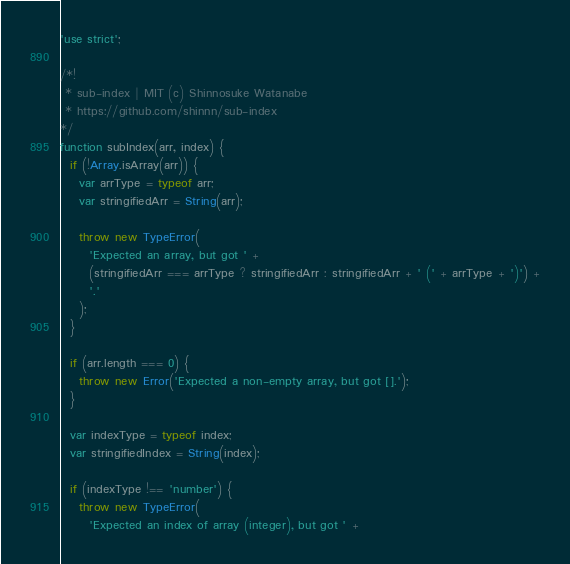Convert code to text. <code><loc_0><loc_0><loc_500><loc_500><_JavaScript_>'use strict';

/*!
 * sub-index | MIT (c) Shinnosuke Watanabe
 * https://github.com/shinnn/sub-index
*/
function subIndex(arr, index) {
  if (!Array.isArray(arr)) {
    var arrType = typeof arr;
    var stringifiedArr = String(arr);

    throw new TypeError(
      'Expected an array, but got ' +
      (stringifiedArr === arrType ? stringifiedArr : stringifiedArr + ' (' + arrType + ')') +
      '.'
    );
  }

  if (arr.length === 0) {
    throw new Error('Expected a non-empty array, but got [].');
  }

  var indexType = typeof index;
  var stringifiedIndex = String(index);

  if (indexType !== 'number') {
    throw new TypeError(
      'Expected an index of array (integer), but got ' +</code> 